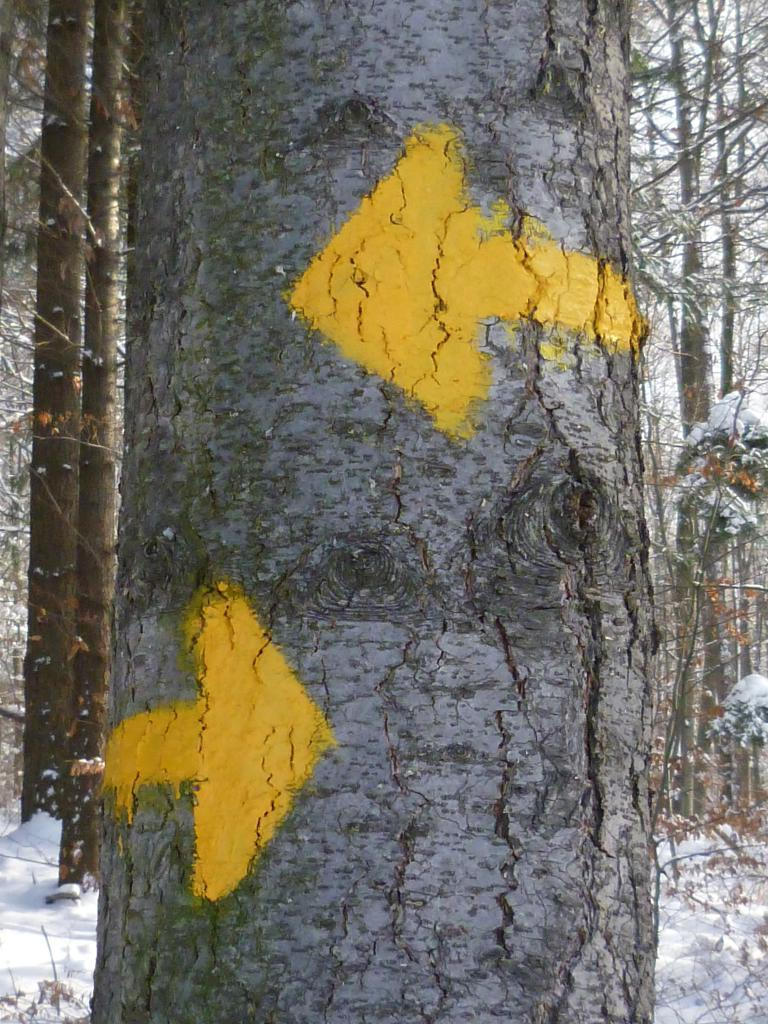What is the main subject in the center of the image? There is a tree in the center of the image. What can be seen in the background of the image? There is snow visible in the background of the image, and there are trees in the background as well. How many spiders can be seen crawling on the tree in the image? There are no spiders visible on the tree in the image. Is there a mitten hanging on the tree in the image? There is no mitten present on the tree in the image. 